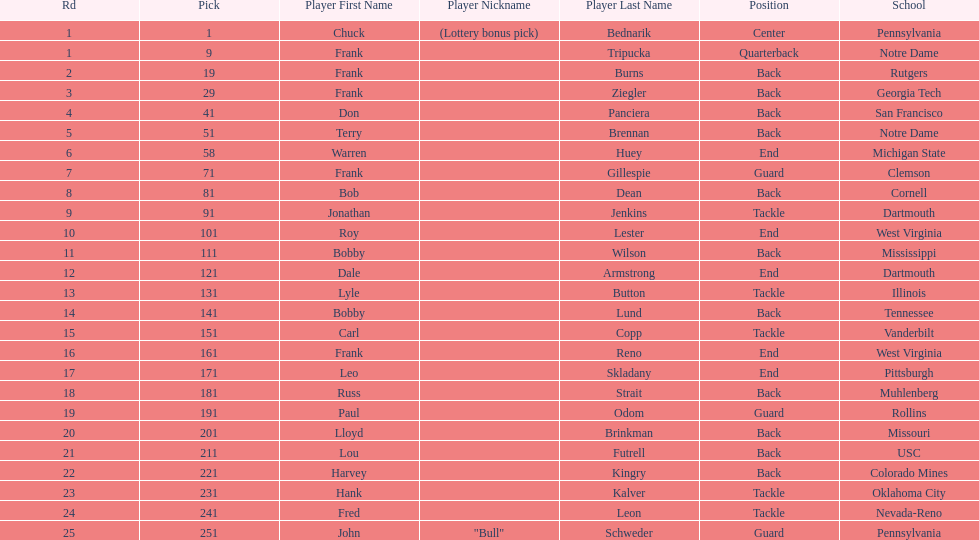Who was picked after roy lester? Bobby Wilson. 